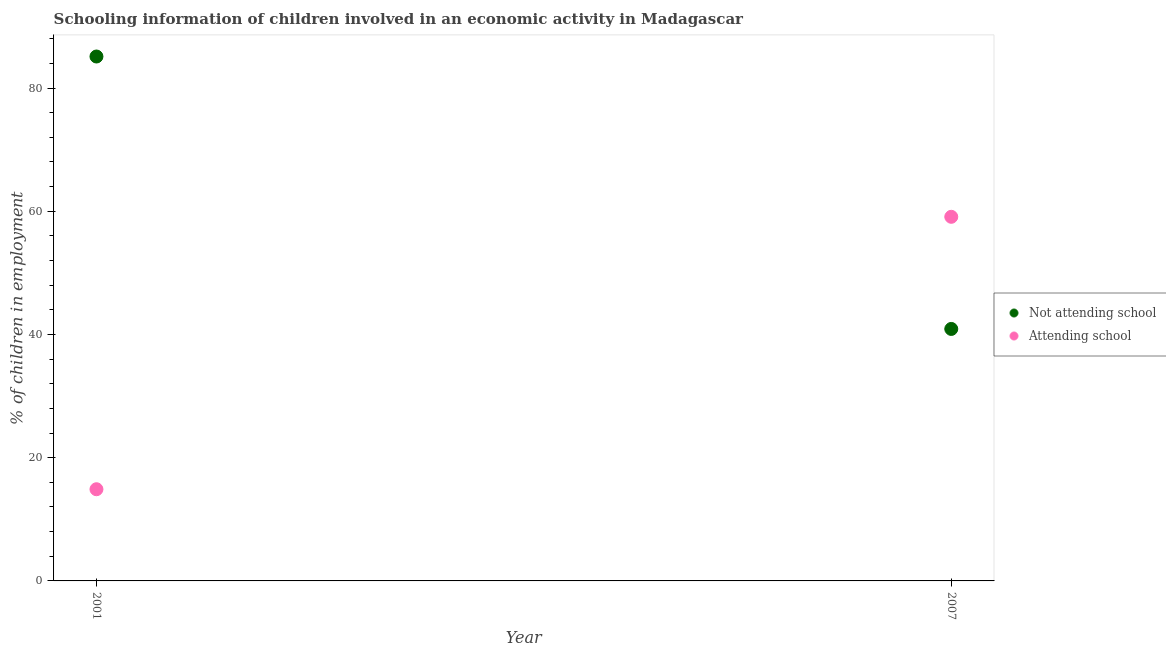Is the number of dotlines equal to the number of legend labels?
Make the answer very short. Yes. What is the percentage of employed children who are not attending school in 2007?
Give a very brief answer. 40.9. Across all years, what is the maximum percentage of employed children who are not attending school?
Your answer should be very brief. 85.12. Across all years, what is the minimum percentage of employed children who are attending school?
Provide a succinct answer. 14.88. In which year was the percentage of employed children who are not attending school maximum?
Your response must be concise. 2001. In which year was the percentage of employed children who are attending school minimum?
Offer a very short reply. 2001. What is the total percentage of employed children who are not attending school in the graph?
Your answer should be compact. 126.02. What is the difference between the percentage of employed children who are attending school in 2001 and that in 2007?
Provide a short and direct response. -44.22. What is the difference between the percentage of employed children who are not attending school in 2007 and the percentage of employed children who are attending school in 2001?
Provide a succinct answer. 26.02. What is the average percentage of employed children who are not attending school per year?
Offer a very short reply. 63.01. In the year 2001, what is the difference between the percentage of employed children who are attending school and percentage of employed children who are not attending school?
Give a very brief answer. -70.24. In how many years, is the percentage of employed children who are attending school greater than 24 %?
Your answer should be compact. 1. What is the ratio of the percentage of employed children who are attending school in 2001 to that in 2007?
Provide a short and direct response. 0.25. Is the percentage of employed children who are not attending school in 2001 less than that in 2007?
Make the answer very short. No. Does the percentage of employed children who are not attending school monotonically increase over the years?
Your answer should be very brief. No. How many dotlines are there?
Offer a very short reply. 2. What is the difference between two consecutive major ticks on the Y-axis?
Keep it short and to the point. 20. How many legend labels are there?
Give a very brief answer. 2. How are the legend labels stacked?
Offer a terse response. Vertical. What is the title of the graph?
Provide a short and direct response. Schooling information of children involved in an economic activity in Madagascar. Does "Imports" appear as one of the legend labels in the graph?
Keep it short and to the point. No. What is the label or title of the Y-axis?
Ensure brevity in your answer.  % of children in employment. What is the % of children in employment in Not attending school in 2001?
Offer a very short reply. 85.12. What is the % of children in employment in Attending school in 2001?
Offer a very short reply. 14.88. What is the % of children in employment of Not attending school in 2007?
Provide a succinct answer. 40.9. What is the % of children in employment of Attending school in 2007?
Ensure brevity in your answer.  59.1. Across all years, what is the maximum % of children in employment in Not attending school?
Provide a succinct answer. 85.12. Across all years, what is the maximum % of children in employment of Attending school?
Keep it short and to the point. 59.1. Across all years, what is the minimum % of children in employment of Not attending school?
Keep it short and to the point. 40.9. Across all years, what is the minimum % of children in employment of Attending school?
Offer a terse response. 14.88. What is the total % of children in employment in Not attending school in the graph?
Provide a short and direct response. 126.02. What is the total % of children in employment in Attending school in the graph?
Your answer should be compact. 73.98. What is the difference between the % of children in employment of Not attending school in 2001 and that in 2007?
Keep it short and to the point. 44.22. What is the difference between the % of children in employment of Attending school in 2001 and that in 2007?
Give a very brief answer. -44.22. What is the difference between the % of children in employment of Not attending school in 2001 and the % of children in employment of Attending school in 2007?
Your answer should be compact. 26.02. What is the average % of children in employment of Not attending school per year?
Keep it short and to the point. 63.01. What is the average % of children in employment in Attending school per year?
Offer a terse response. 36.99. In the year 2001, what is the difference between the % of children in employment of Not attending school and % of children in employment of Attending school?
Your answer should be very brief. 70.24. In the year 2007, what is the difference between the % of children in employment in Not attending school and % of children in employment in Attending school?
Offer a very short reply. -18.2. What is the ratio of the % of children in employment of Not attending school in 2001 to that in 2007?
Your answer should be compact. 2.08. What is the ratio of the % of children in employment of Attending school in 2001 to that in 2007?
Make the answer very short. 0.25. What is the difference between the highest and the second highest % of children in employment in Not attending school?
Make the answer very short. 44.22. What is the difference between the highest and the second highest % of children in employment in Attending school?
Provide a short and direct response. 44.22. What is the difference between the highest and the lowest % of children in employment of Not attending school?
Provide a succinct answer. 44.22. What is the difference between the highest and the lowest % of children in employment of Attending school?
Provide a short and direct response. 44.22. 